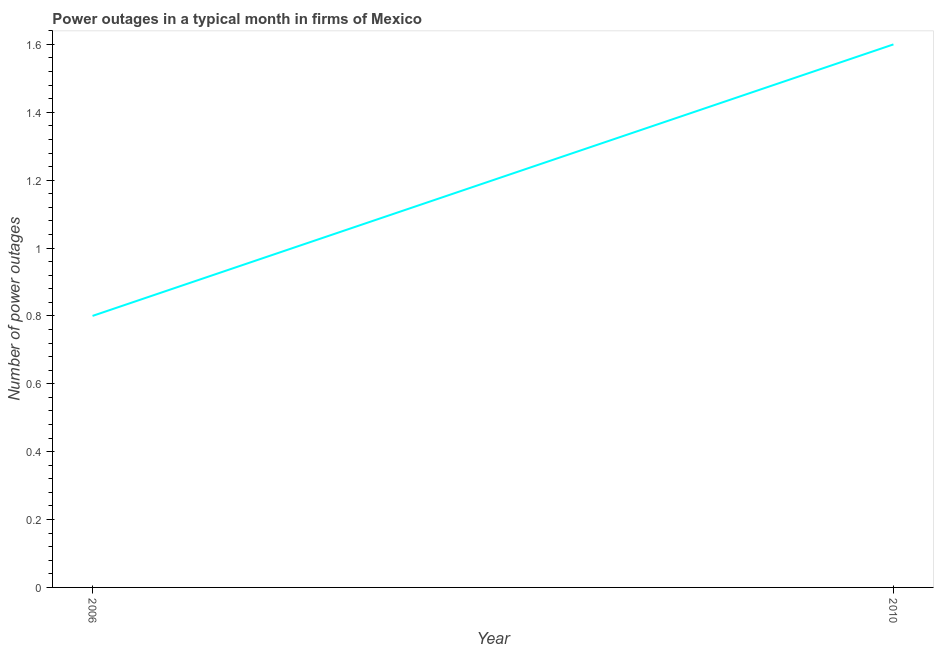What is the number of power outages in 2006?
Your answer should be compact. 0.8. Across all years, what is the maximum number of power outages?
Ensure brevity in your answer.  1.6. In which year was the number of power outages minimum?
Offer a very short reply. 2006. What is the sum of the number of power outages?
Give a very brief answer. 2.4. What is the average number of power outages per year?
Keep it short and to the point. 1.2. What is the median number of power outages?
Make the answer very short. 1.2. In how many years, is the number of power outages greater than 0.36 ?
Offer a very short reply. 2. Do a majority of the years between 2010 and 2006 (inclusive) have number of power outages greater than 1.04 ?
Keep it short and to the point. No. Is the number of power outages in 2006 less than that in 2010?
Ensure brevity in your answer.  Yes. In how many years, is the number of power outages greater than the average number of power outages taken over all years?
Provide a succinct answer. 1. How many years are there in the graph?
Your response must be concise. 2. Does the graph contain any zero values?
Your answer should be compact. No. Does the graph contain grids?
Your response must be concise. No. What is the title of the graph?
Provide a short and direct response. Power outages in a typical month in firms of Mexico. What is the label or title of the X-axis?
Your answer should be very brief. Year. What is the label or title of the Y-axis?
Your answer should be compact. Number of power outages. What is the difference between the Number of power outages in 2006 and 2010?
Make the answer very short. -0.8. What is the ratio of the Number of power outages in 2006 to that in 2010?
Make the answer very short. 0.5. 